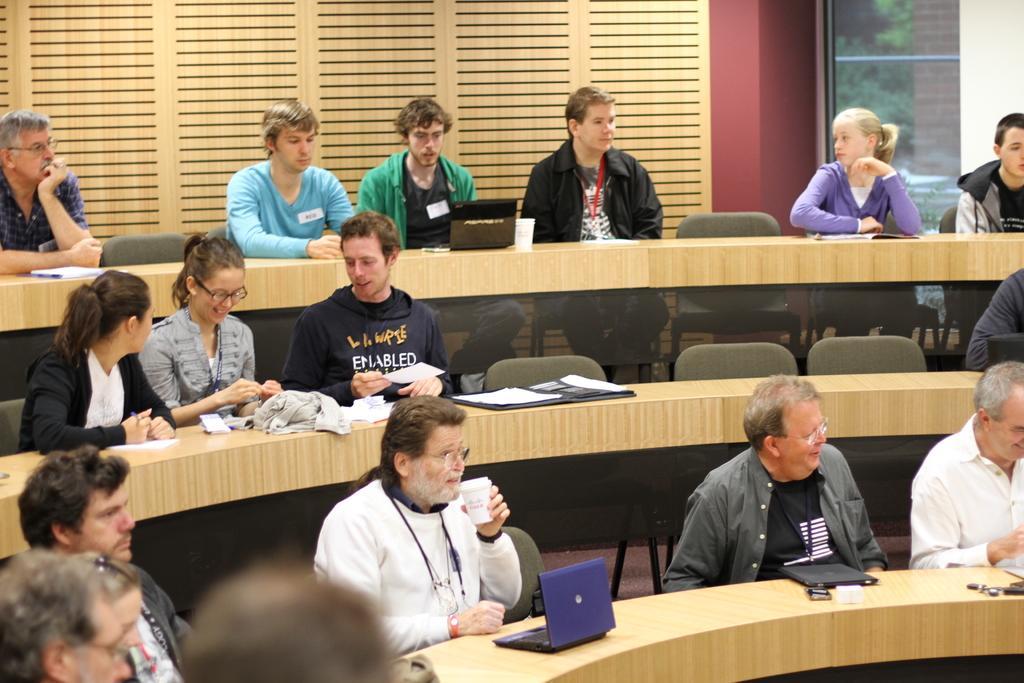Could you give a brief overview of what you see in this image? In this image it seems like a class room in which there are different types of students sitting in the chair. There is a desk in front of them. On the desk there is laptop,file,clothes,book. At the background there is a wall in the middle and window to the right side. 